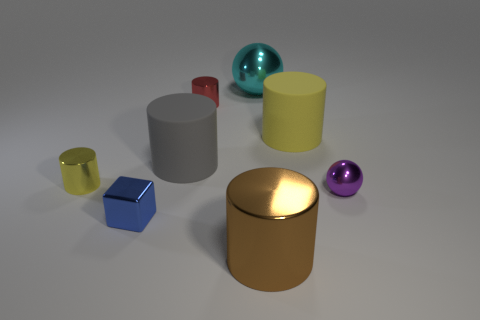How many objects can be classified as spheres? In the given image, there are two objects that can be classified as spheres. 